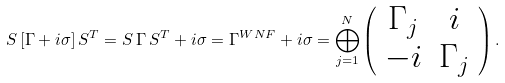Convert formula to latex. <formula><loc_0><loc_0><loc_500><loc_500>S \, [ \Gamma + i \sigma ] \, S ^ { T } = S \, \Gamma \, S ^ { T } + i \sigma = \Gamma ^ { W N F } + i \sigma = \bigoplus _ { j = 1 } ^ { N } \left ( \begin{array} { c c } \Gamma _ { j } & i \\ - i & \Gamma _ { j } \end{array} \right ) .</formula> 